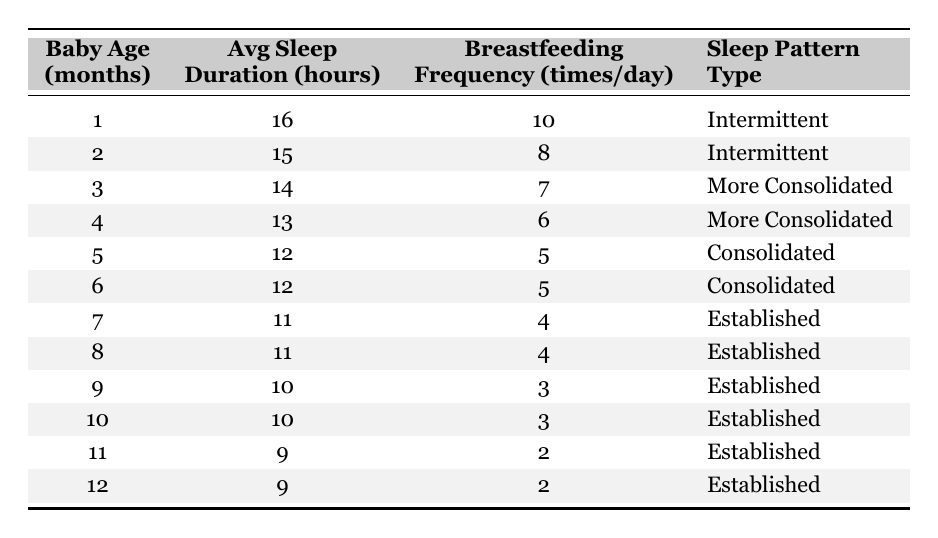What is the average sleep duration for a 3-month-old baby? According to the table, the average sleep duration for a 3-month-old baby is listed as 14 hours.
Answer: 14 hours How many times a day does a 1-month-old baby breastfeed on average? The table indicates that a 1-month-old baby breastfeeds an average of 10 times a day.
Answer: 10 times What sleep pattern type is observed for babies aged 5 and 6 months? The table shows that both 5-month-old and 6-month-old babies have a "Consolidated" sleep pattern type.
Answer: Consolidated Does the average sleep duration decrease as the baby grows older? By examining the table, we see that the average sleep duration decreases as the age increases, from 16 hours at 1 month to 9 hours at 12 months.
Answer: Yes What is the difference in average sleep duration between a 1-month-old and a 12-month-old baby? The average sleep duration for a 1-month-old is 16 hours, and for a 12-month-old, it is 9 hours. The difference is 16 - 9 = 7 hours.
Answer: 7 hours For which age group is the breastfeeding frequency the highest according to the table? The table shows that the highest breastfeeding frequency is for the 1-month-old age group, with 10 times a day.
Answer: 1 month What is the average breastfeeding frequency for babies aged 4 to 6 months? The frequencies for ages 4, 5, and 6 months are 6, 5, and 5 respectively. The average is (6 + 5 + 5) / 3 = 5.33, which rounds to approximately 5.
Answer: 5 Are all babies aged 7 months and older categorized under the same sleep pattern type? The table indicates that all babies aged 7 months and older have the sleep pattern type labeled as "Established."
Answer: Yes How does the sleep pattern type change as babies age from 1 month to 5 months? The table shows that the sleep pattern type changes from "Intermittent" at 1 month to "More Consolidated" at 3 and 4 months, and finally to "Consolidated" by 5 months.
Answer: It changes from Intermittent to More Consolidated, then to Consolidated Is there a consistent breastfeeding frequency for babies from 7 to 12 months? The breastfeeding frequency starts at 4 times a day for 7 and 8-month-olds and then decreases to 2 times a day for 11 and 12-month-olds. Hence, it is not consistent.
Answer: No 